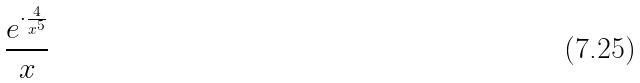<formula> <loc_0><loc_0><loc_500><loc_500>\frac { e ^ { \cdot \frac { 4 } { x ^ { 5 } } } } { x }</formula> 